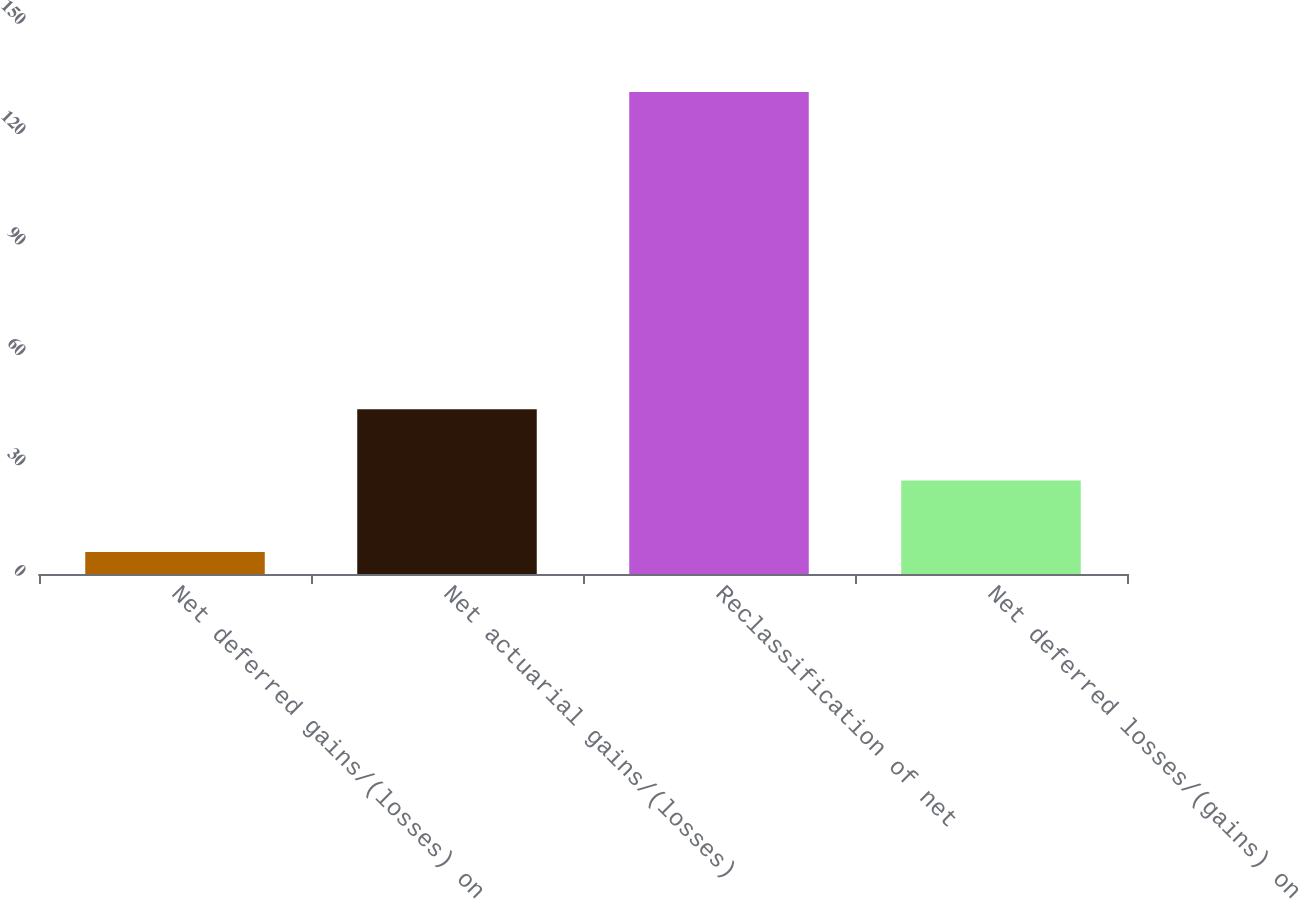<chart> <loc_0><loc_0><loc_500><loc_500><bar_chart><fcel>Net deferred gains/(losses) on<fcel>Net actuarial gains/(losses)<fcel>Reclassification of net<fcel>Net deferred losses/(gains) on<nl><fcel>6<fcel>44.8<fcel>131<fcel>25.4<nl></chart> 